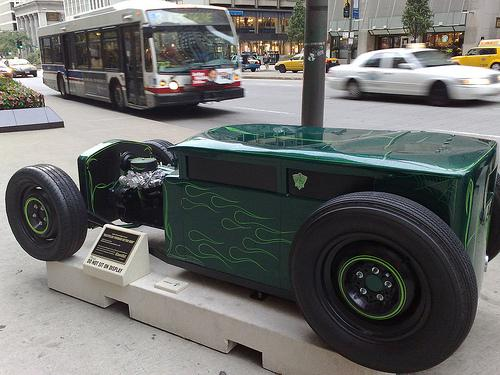Question: where was picture taken?
Choices:
A. In a train.
B. On an airplane.
C. On the street.
D. In a building.
Answer with the letter. Answer: C Question: what color is ride on sidewalk?
Choices:
A. Green and black.
B. Blue and Yellow.
C. Red and White.
D. Orange and Tan.
Answer with the letter. Answer: A Question: what is in the background?
Choices:
A. People.
B. Bus.
C. A tree.
D. Clothes.
Answer with the letter. Answer: B 